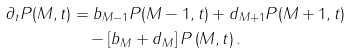<formula> <loc_0><loc_0><loc_500><loc_500>\partial _ { t } P ( M , t ) & = b _ { M - 1 } P ( M - 1 , t ) + d _ { M + 1 } P ( M + 1 , t ) \\ & \quad - \left [ b _ { M } + d _ { M } \right ] P \left ( M , t \right ) .</formula> 